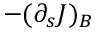Convert formula to latex. <formula><loc_0><loc_0><loc_500><loc_500>- ( \partial _ { s } J ) _ { B }</formula> 